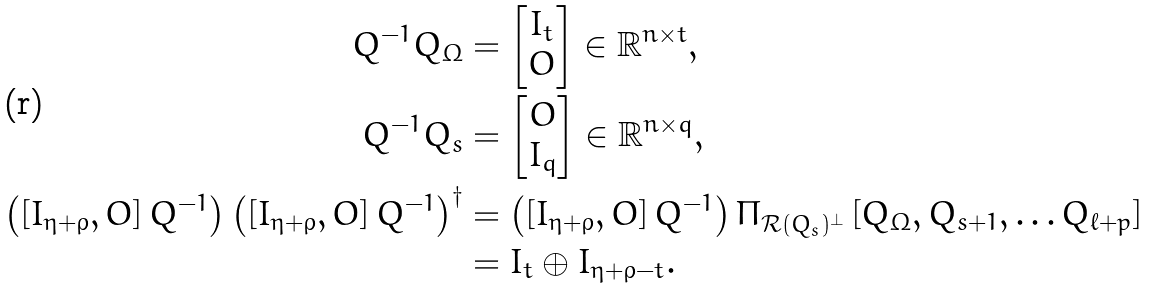<formula> <loc_0><loc_0><loc_500><loc_500>Q ^ { - 1 } Q _ { \Omega } & = \begin{bmatrix} I _ { t } \\ O \end{bmatrix} \in \mathbb { R } ^ { n \times t } , \\ Q ^ { - 1 } Q _ { s } & = \begin{bmatrix} O \\ I _ { q } \end{bmatrix} \in \mathbb { R } ^ { n \times q } , \\ \left ( \left [ I _ { \eta + \rho } , O \right ] Q ^ { - 1 } \right ) \left ( \left [ I _ { \eta + \rho } , O \right ] Q ^ { - 1 } \right ) ^ { \dag } & = \left ( \left [ I _ { \eta + \rho } , O \right ] Q ^ { - 1 } \right ) \Pi _ { \mathcal { R } ( Q _ { s } ) ^ { \perp } } \left [ Q _ { \Omega } , Q _ { s + 1 } , \dots Q _ { \ell + p } \right ] \\ & = I _ { t } \oplus I _ { \eta + \rho - t } .</formula> 